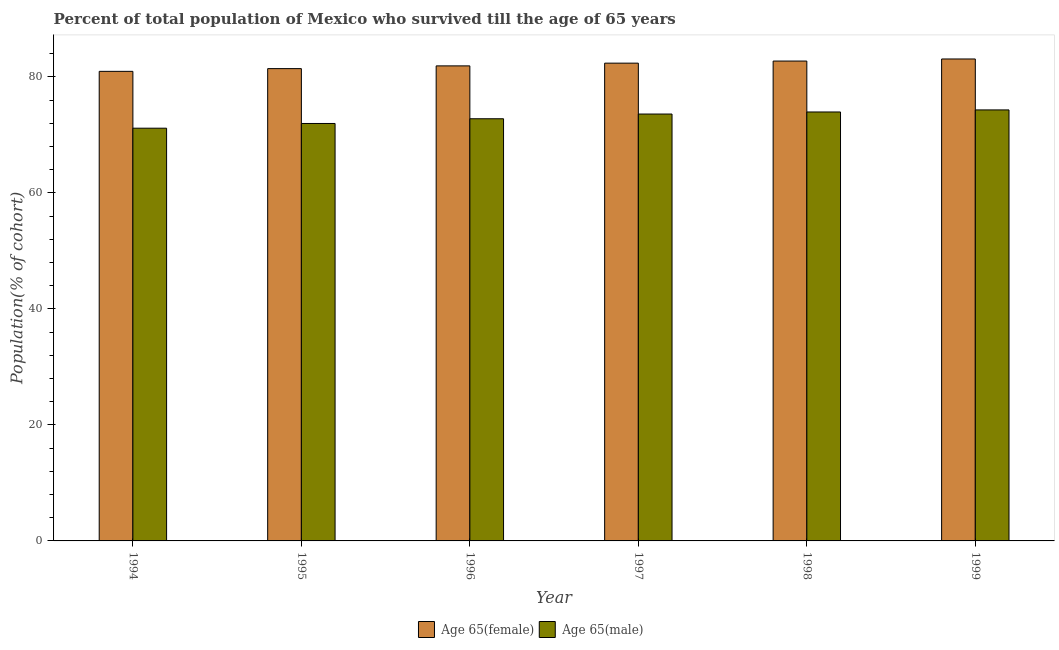How many bars are there on the 4th tick from the left?
Give a very brief answer. 2. In how many cases, is the number of bars for a given year not equal to the number of legend labels?
Make the answer very short. 0. What is the percentage of female population who survived till age of 65 in 1997?
Your answer should be compact. 82.37. Across all years, what is the maximum percentage of female population who survived till age of 65?
Provide a short and direct response. 83.08. Across all years, what is the minimum percentage of female population who survived till age of 65?
Keep it short and to the point. 80.95. In which year was the percentage of male population who survived till age of 65 maximum?
Provide a succinct answer. 1999. In which year was the percentage of male population who survived till age of 65 minimum?
Provide a succinct answer. 1994. What is the total percentage of female population who survived till age of 65 in the graph?
Ensure brevity in your answer.  492.44. What is the difference between the percentage of female population who survived till age of 65 in 1995 and that in 1997?
Your answer should be very brief. -0.94. What is the difference between the percentage of male population who survived till age of 65 in 1996 and the percentage of female population who survived till age of 65 in 1995?
Keep it short and to the point. 0.81. What is the average percentage of male population who survived till age of 65 per year?
Ensure brevity in your answer.  72.96. In the year 1998, what is the difference between the percentage of female population who survived till age of 65 and percentage of male population who survived till age of 65?
Keep it short and to the point. 0. In how many years, is the percentage of female population who survived till age of 65 greater than 16 %?
Your answer should be compact. 6. What is the ratio of the percentage of female population who survived till age of 65 in 1996 to that in 1997?
Ensure brevity in your answer.  0.99. Is the percentage of female population who survived till age of 65 in 1997 less than that in 1998?
Offer a terse response. Yes. What is the difference between the highest and the second highest percentage of male population who survived till age of 65?
Give a very brief answer. 0.36. What is the difference between the highest and the lowest percentage of male population who survived till age of 65?
Offer a very short reply. 3.15. Is the sum of the percentage of male population who survived till age of 65 in 1996 and 1997 greater than the maximum percentage of female population who survived till age of 65 across all years?
Your answer should be compact. Yes. What does the 2nd bar from the left in 1995 represents?
Your answer should be very brief. Age 65(male). What does the 1st bar from the right in 1996 represents?
Your answer should be compact. Age 65(male). How many bars are there?
Make the answer very short. 12. Are all the bars in the graph horizontal?
Your answer should be very brief. No. Does the graph contain any zero values?
Your response must be concise. No. Where does the legend appear in the graph?
Your answer should be very brief. Bottom center. How many legend labels are there?
Your response must be concise. 2. How are the legend labels stacked?
Offer a very short reply. Horizontal. What is the title of the graph?
Your answer should be compact. Percent of total population of Mexico who survived till the age of 65 years. Does "Nitrous oxide emissions" appear as one of the legend labels in the graph?
Ensure brevity in your answer.  No. What is the label or title of the X-axis?
Your response must be concise. Year. What is the label or title of the Y-axis?
Give a very brief answer. Population(% of cohort). What is the Population(% of cohort) in Age 65(female) in 1994?
Your response must be concise. 80.95. What is the Population(% of cohort) of Age 65(male) in 1994?
Provide a succinct answer. 71.15. What is the Population(% of cohort) of Age 65(female) in 1995?
Provide a succinct answer. 81.42. What is the Population(% of cohort) in Age 65(male) in 1995?
Offer a very short reply. 71.96. What is the Population(% of cohort) in Age 65(female) in 1996?
Offer a terse response. 81.89. What is the Population(% of cohort) in Age 65(male) in 1996?
Offer a very short reply. 72.78. What is the Population(% of cohort) in Age 65(female) in 1997?
Your response must be concise. 82.37. What is the Population(% of cohort) in Age 65(male) in 1997?
Ensure brevity in your answer.  73.59. What is the Population(% of cohort) of Age 65(female) in 1998?
Provide a succinct answer. 82.73. What is the Population(% of cohort) in Age 65(male) in 1998?
Make the answer very short. 73.95. What is the Population(% of cohort) of Age 65(female) in 1999?
Keep it short and to the point. 83.08. What is the Population(% of cohort) of Age 65(male) in 1999?
Offer a very short reply. 74.3. Across all years, what is the maximum Population(% of cohort) of Age 65(female)?
Ensure brevity in your answer.  83.08. Across all years, what is the maximum Population(% of cohort) of Age 65(male)?
Offer a very short reply. 74.3. Across all years, what is the minimum Population(% of cohort) of Age 65(female)?
Offer a very short reply. 80.95. Across all years, what is the minimum Population(% of cohort) of Age 65(male)?
Your response must be concise. 71.15. What is the total Population(% of cohort) in Age 65(female) in the graph?
Offer a very short reply. 492.44. What is the total Population(% of cohort) in Age 65(male) in the graph?
Your response must be concise. 437.74. What is the difference between the Population(% of cohort) of Age 65(female) in 1994 and that in 1995?
Keep it short and to the point. -0.47. What is the difference between the Population(% of cohort) of Age 65(male) in 1994 and that in 1995?
Provide a succinct answer. -0.81. What is the difference between the Population(% of cohort) of Age 65(female) in 1994 and that in 1996?
Give a very brief answer. -0.94. What is the difference between the Population(% of cohort) of Age 65(male) in 1994 and that in 1996?
Give a very brief answer. -1.63. What is the difference between the Population(% of cohort) in Age 65(female) in 1994 and that in 1997?
Keep it short and to the point. -1.42. What is the difference between the Population(% of cohort) of Age 65(male) in 1994 and that in 1997?
Give a very brief answer. -2.44. What is the difference between the Population(% of cohort) of Age 65(female) in 1994 and that in 1998?
Offer a very short reply. -1.77. What is the difference between the Population(% of cohort) in Age 65(male) in 1994 and that in 1998?
Keep it short and to the point. -2.8. What is the difference between the Population(% of cohort) of Age 65(female) in 1994 and that in 1999?
Provide a succinct answer. -2.13. What is the difference between the Population(% of cohort) in Age 65(male) in 1994 and that in 1999?
Ensure brevity in your answer.  -3.15. What is the difference between the Population(% of cohort) of Age 65(female) in 1995 and that in 1996?
Keep it short and to the point. -0.47. What is the difference between the Population(% of cohort) in Age 65(male) in 1995 and that in 1996?
Your answer should be compact. -0.81. What is the difference between the Population(% of cohort) of Age 65(female) in 1995 and that in 1997?
Your answer should be very brief. -0.94. What is the difference between the Population(% of cohort) of Age 65(male) in 1995 and that in 1997?
Offer a terse response. -1.63. What is the difference between the Population(% of cohort) of Age 65(female) in 1995 and that in 1998?
Your answer should be very brief. -1.3. What is the difference between the Population(% of cohort) in Age 65(male) in 1995 and that in 1998?
Provide a short and direct response. -1.98. What is the difference between the Population(% of cohort) in Age 65(female) in 1995 and that in 1999?
Provide a succinct answer. -1.66. What is the difference between the Population(% of cohort) of Age 65(male) in 1995 and that in 1999?
Make the answer very short. -2.34. What is the difference between the Population(% of cohort) in Age 65(female) in 1996 and that in 1997?
Keep it short and to the point. -0.47. What is the difference between the Population(% of cohort) in Age 65(male) in 1996 and that in 1997?
Ensure brevity in your answer.  -0.81. What is the difference between the Population(% of cohort) of Age 65(female) in 1996 and that in 1998?
Make the answer very short. -0.83. What is the difference between the Population(% of cohort) of Age 65(male) in 1996 and that in 1998?
Keep it short and to the point. -1.17. What is the difference between the Population(% of cohort) of Age 65(female) in 1996 and that in 1999?
Provide a short and direct response. -1.19. What is the difference between the Population(% of cohort) in Age 65(male) in 1996 and that in 1999?
Give a very brief answer. -1.52. What is the difference between the Population(% of cohort) of Age 65(female) in 1997 and that in 1998?
Make the answer very short. -0.36. What is the difference between the Population(% of cohort) of Age 65(male) in 1997 and that in 1998?
Ensure brevity in your answer.  -0.36. What is the difference between the Population(% of cohort) of Age 65(female) in 1997 and that in 1999?
Offer a very short reply. -0.72. What is the difference between the Population(% of cohort) of Age 65(male) in 1997 and that in 1999?
Make the answer very short. -0.71. What is the difference between the Population(% of cohort) of Age 65(female) in 1998 and that in 1999?
Give a very brief answer. -0.36. What is the difference between the Population(% of cohort) of Age 65(male) in 1998 and that in 1999?
Make the answer very short. -0.36. What is the difference between the Population(% of cohort) in Age 65(female) in 1994 and the Population(% of cohort) in Age 65(male) in 1995?
Your answer should be compact. 8.99. What is the difference between the Population(% of cohort) in Age 65(female) in 1994 and the Population(% of cohort) in Age 65(male) in 1996?
Offer a terse response. 8.17. What is the difference between the Population(% of cohort) in Age 65(female) in 1994 and the Population(% of cohort) in Age 65(male) in 1997?
Provide a succinct answer. 7.36. What is the difference between the Population(% of cohort) in Age 65(female) in 1994 and the Population(% of cohort) in Age 65(male) in 1998?
Keep it short and to the point. 7. What is the difference between the Population(% of cohort) of Age 65(female) in 1994 and the Population(% of cohort) of Age 65(male) in 1999?
Ensure brevity in your answer.  6.65. What is the difference between the Population(% of cohort) in Age 65(female) in 1995 and the Population(% of cohort) in Age 65(male) in 1996?
Your answer should be very brief. 8.64. What is the difference between the Population(% of cohort) in Age 65(female) in 1995 and the Population(% of cohort) in Age 65(male) in 1997?
Your answer should be compact. 7.83. What is the difference between the Population(% of cohort) of Age 65(female) in 1995 and the Population(% of cohort) of Age 65(male) in 1998?
Your answer should be compact. 7.47. What is the difference between the Population(% of cohort) in Age 65(female) in 1995 and the Population(% of cohort) in Age 65(male) in 1999?
Keep it short and to the point. 7.12. What is the difference between the Population(% of cohort) in Age 65(female) in 1996 and the Population(% of cohort) in Age 65(male) in 1997?
Offer a very short reply. 8.3. What is the difference between the Population(% of cohort) of Age 65(female) in 1996 and the Population(% of cohort) of Age 65(male) in 1998?
Provide a succinct answer. 7.95. What is the difference between the Population(% of cohort) of Age 65(female) in 1996 and the Population(% of cohort) of Age 65(male) in 1999?
Provide a succinct answer. 7.59. What is the difference between the Population(% of cohort) of Age 65(female) in 1997 and the Population(% of cohort) of Age 65(male) in 1998?
Your response must be concise. 8.42. What is the difference between the Population(% of cohort) of Age 65(female) in 1997 and the Population(% of cohort) of Age 65(male) in 1999?
Offer a terse response. 8.06. What is the difference between the Population(% of cohort) of Age 65(female) in 1998 and the Population(% of cohort) of Age 65(male) in 1999?
Your answer should be very brief. 8.42. What is the average Population(% of cohort) in Age 65(female) per year?
Give a very brief answer. 82.07. What is the average Population(% of cohort) in Age 65(male) per year?
Your response must be concise. 72.96. In the year 1994, what is the difference between the Population(% of cohort) of Age 65(female) and Population(% of cohort) of Age 65(male)?
Provide a short and direct response. 9.8. In the year 1995, what is the difference between the Population(% of cohort) of Age 65(female) and Population(% of cohort) of Age 65(male)?
Your answer should be compact. 9.46. In the year 1996, what is the difference between the Population(% of cohort) in Age 65(female) and Population(% of cohort) in Age 65(male)?
Your answer should be very brief. 9.12. In the year 1997, what is the difference between the Population(% of cohort) in Age 65(female) and Population(% of cohort) in Age 65(male)?
Your answer should be compact. 8.77. In the year 1998, what is the difference between the Population(% of cohort) in Age 65(female) and Population(% of cohort) in Age 65(male)?
Offer a terse response. 8.78. In the year 1999, what is the difference between the Population(% of cohort) in Age 65(female) and Population(% of cohort) in Age 65(male)?
Ensure brevity in your answer.  8.78. What is the ratio of the Population(% of cohort) in Age 65(female) in 1994 to that in 1995?
Your response must be concise. 0.99. What is the ratio of the Population(% of cohort) in Age 65(male) in 1994 to that in 1995?
Your response must be concise. 0.99. What is the ratio of the Population(% of cohort) in Age 65(male) in 1994 to that in 1996?
Keep it short and to the point. 0.98. What is the ratio of the Population(% of cohort) of Age 65(female) in 1994 to that in 1997?
Your response must be concise. 0.98. What is the ratio of the Population(% of cohort) in Age 65(male) in 1994 to that in 1997?
Offer a terse response. 0.97. What is the ratio of the Population(% of cohort) of Age 65(female) in 1994 to that in 1998?
Offer a very short reply. 0.98. What is the ratio of the Population(% of cohort) in Age 65(male) in 1994 to that in 1998?
Your response must be concise. 0.96. What is the ratio of the Population(% of cohort) of Age 65(female) in 1994 to that in 1999?
Offer a very short reply. 0.97. What is the ratio of the Population(% of cohort) of Age 65(male) in 1994 to that in 1999?
Make the answer very short. 0.96. What is the ratio of the Population(% of cohort) in Age 65(female) in 1995 to that in 1996?
Provide a short and direct response. 0.99. What is the ratio of the Population(% of cohort) of Age 65(female) in 1995 to that in 1997?
Ensure brevity in your answer.  0.99. What is the ratio of the Population(% of cohort) in Age 65(male) in 1995 to that in 1997?
Provide a succinct answer. 0.98. What is the ratio of the Population(% of cohort) of Age 65(female) in 1995 to that in 1998?
Offer a terse response. 0.98. What is the ratio of the Population(% of cohort) of Age 65(male) in 1995 to that in 1998?
Offer a very short reply. 0.97. What is the ratio of the Population(% of cohort) of Age 65(male) in 1995 to that in 1999?
Provide a short and direct response. 0.97. What is the ratio of the Population(% of cohort) of Age 65(female) in 1996 to that in 1997?
Provide a succinct answer. 0.99. What is the ratio of the Population(% of cohort) of Age 65(male) in 1996 to that in 1997?
Give a very brief answer. 0.99. What is the ratio of the Population(% of cohort) in Age 65(female) in 1996 to that in 1998?
Give a very brief answer. 0.99. What is the ratio of the Population(% of cohort) of Age 65(male) in 1996 to that in 1998?
Provide a short and direct response. 0.98. What is the ratio of the Population(% of cohort) in Age 65(female) in 1996 to that in 1999?
Offer a very short reply. 0.99. What is the ratio of the Population(% of cohort) in Age 65(male) in 1996 to that in 1999?
Give a very brief answer. 0.98. What is the difference between the highest and the second highest Population(% of cohort) of Age 65(female)?
Provide a short and direct response. 0.36. What is the difference between the highest and the second highest Population(% of cohort) of Age 65(male)?
Offer a terse response. 0.36. What is the difference between the highest and the lowest Population(% of cohort) of Age 65(female)?
Your answer should be compact. 2.13. What is the difference between the highest and the lowest Population(% of cohort) in Age 65(male)?
Offer a terse response. 3.15. 